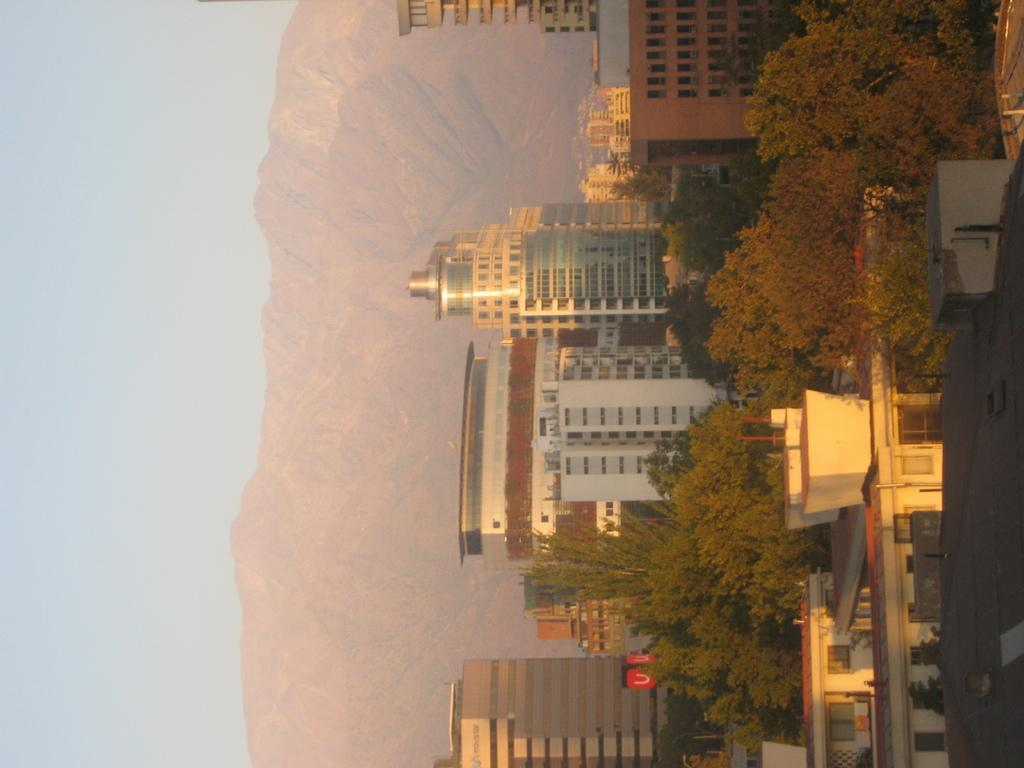What type of structures can be seen in the image? There is a group of buildings in the image. What other natural elements are present in the image? There are trees in the image. Are there any man-made objects that provide information or directions? Yes, there are sign boards in the image. What can be seen in the distance in the background of the image? Mountains and the sky are visible in the background of the image. Where are the books located in the image? There are no books present in the image. What type of club can be seen in the image? There is no club present in the image. 